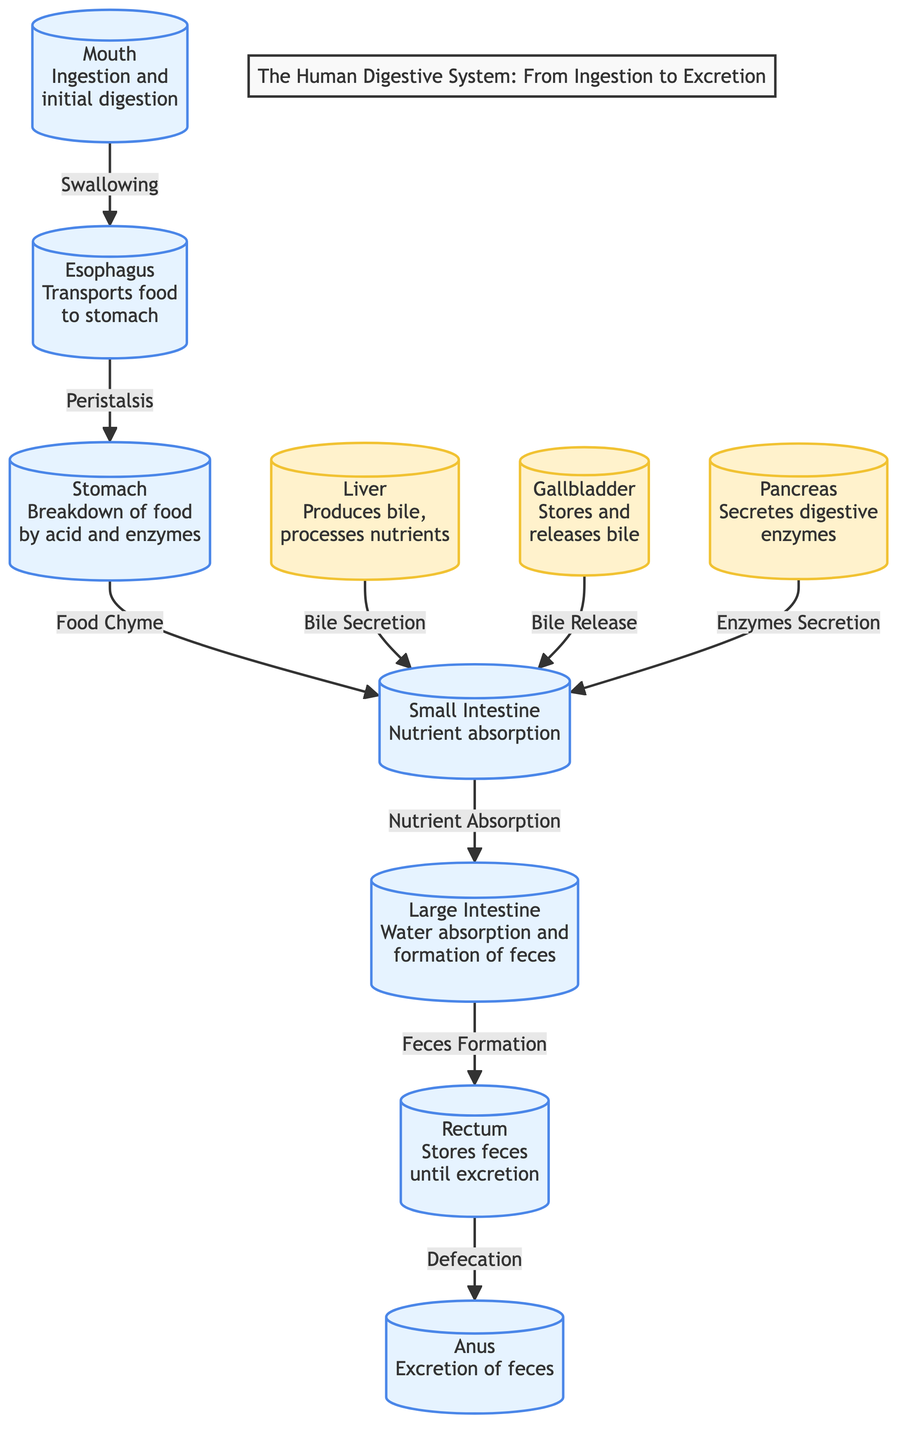What is the first organ in the digestive system? The diagram starts with the mouth, which is labeled as the first organ involved in ingestion and initial digestion.
Answer: Mouth How many organs are involved in the digestive process according to the diagram? By counting the labeled organs in the diagram, we can see there are ten different organs listed that play a role in digestion.
Answer: 10 What is the function of the liver in the digestive system? The liver is described in the diagram as producing bile and processing nutrients, which indicates its crucial role in digestion and nutrient management.
Answer: Produces bile, processes nutrients Which organ performs nutrient absorption? The small intestine is specifically labeled as the organ responsible for nutrient absorption, indicating its primary function within the digestive system.
Answer: Small Intestine What method does the esophagus use to transport food to the stomach? The diagram indicates that the esophagus transports food through a process called peristalsis, which is a series of wave-like muscle contractions.
Answer: Peristalsis What releases bile into the small intestine? The gallbladder is responsible for storing and releasing bile into the small intestine, as shown in the diagram by the connection labeled “Bile Release.”
Answer: Gallbladder How is feces formed in the digestive system? According to the diagram, feces formation occurs in the large intestine as a result of water absorption, which consolidates waste material.
Answer: Water absorption What is the final step of the digestive process shown in the diagram? The final step labeled in the diagram is "Defecation," which occurs at the anus where feces is excreted from the body.
Answer: Defecation Which organ is located between the stomach and the large intestine? The small intestine is located between the stomach and the large intestine, as shown in the directional flow of the digestion process in the diagram.
Answer: Small Intestine What does the pancreas secrete for digestion? The pancreas is indicated in the diagram as secreting digestive enzymes, highlighting its role in aiding the digestive process.
Answer: Digestive enzymes 